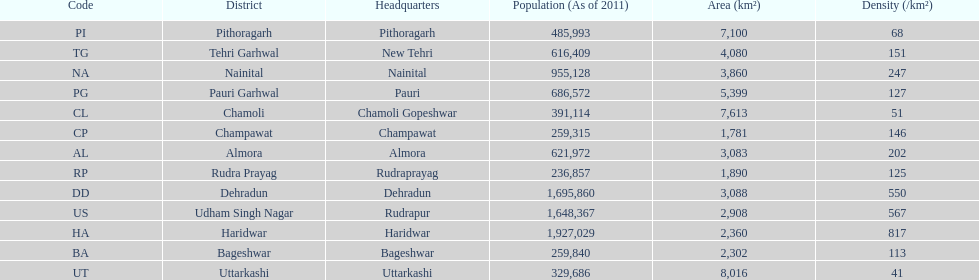What is the next most populous district after haridwar? Dehradun. 